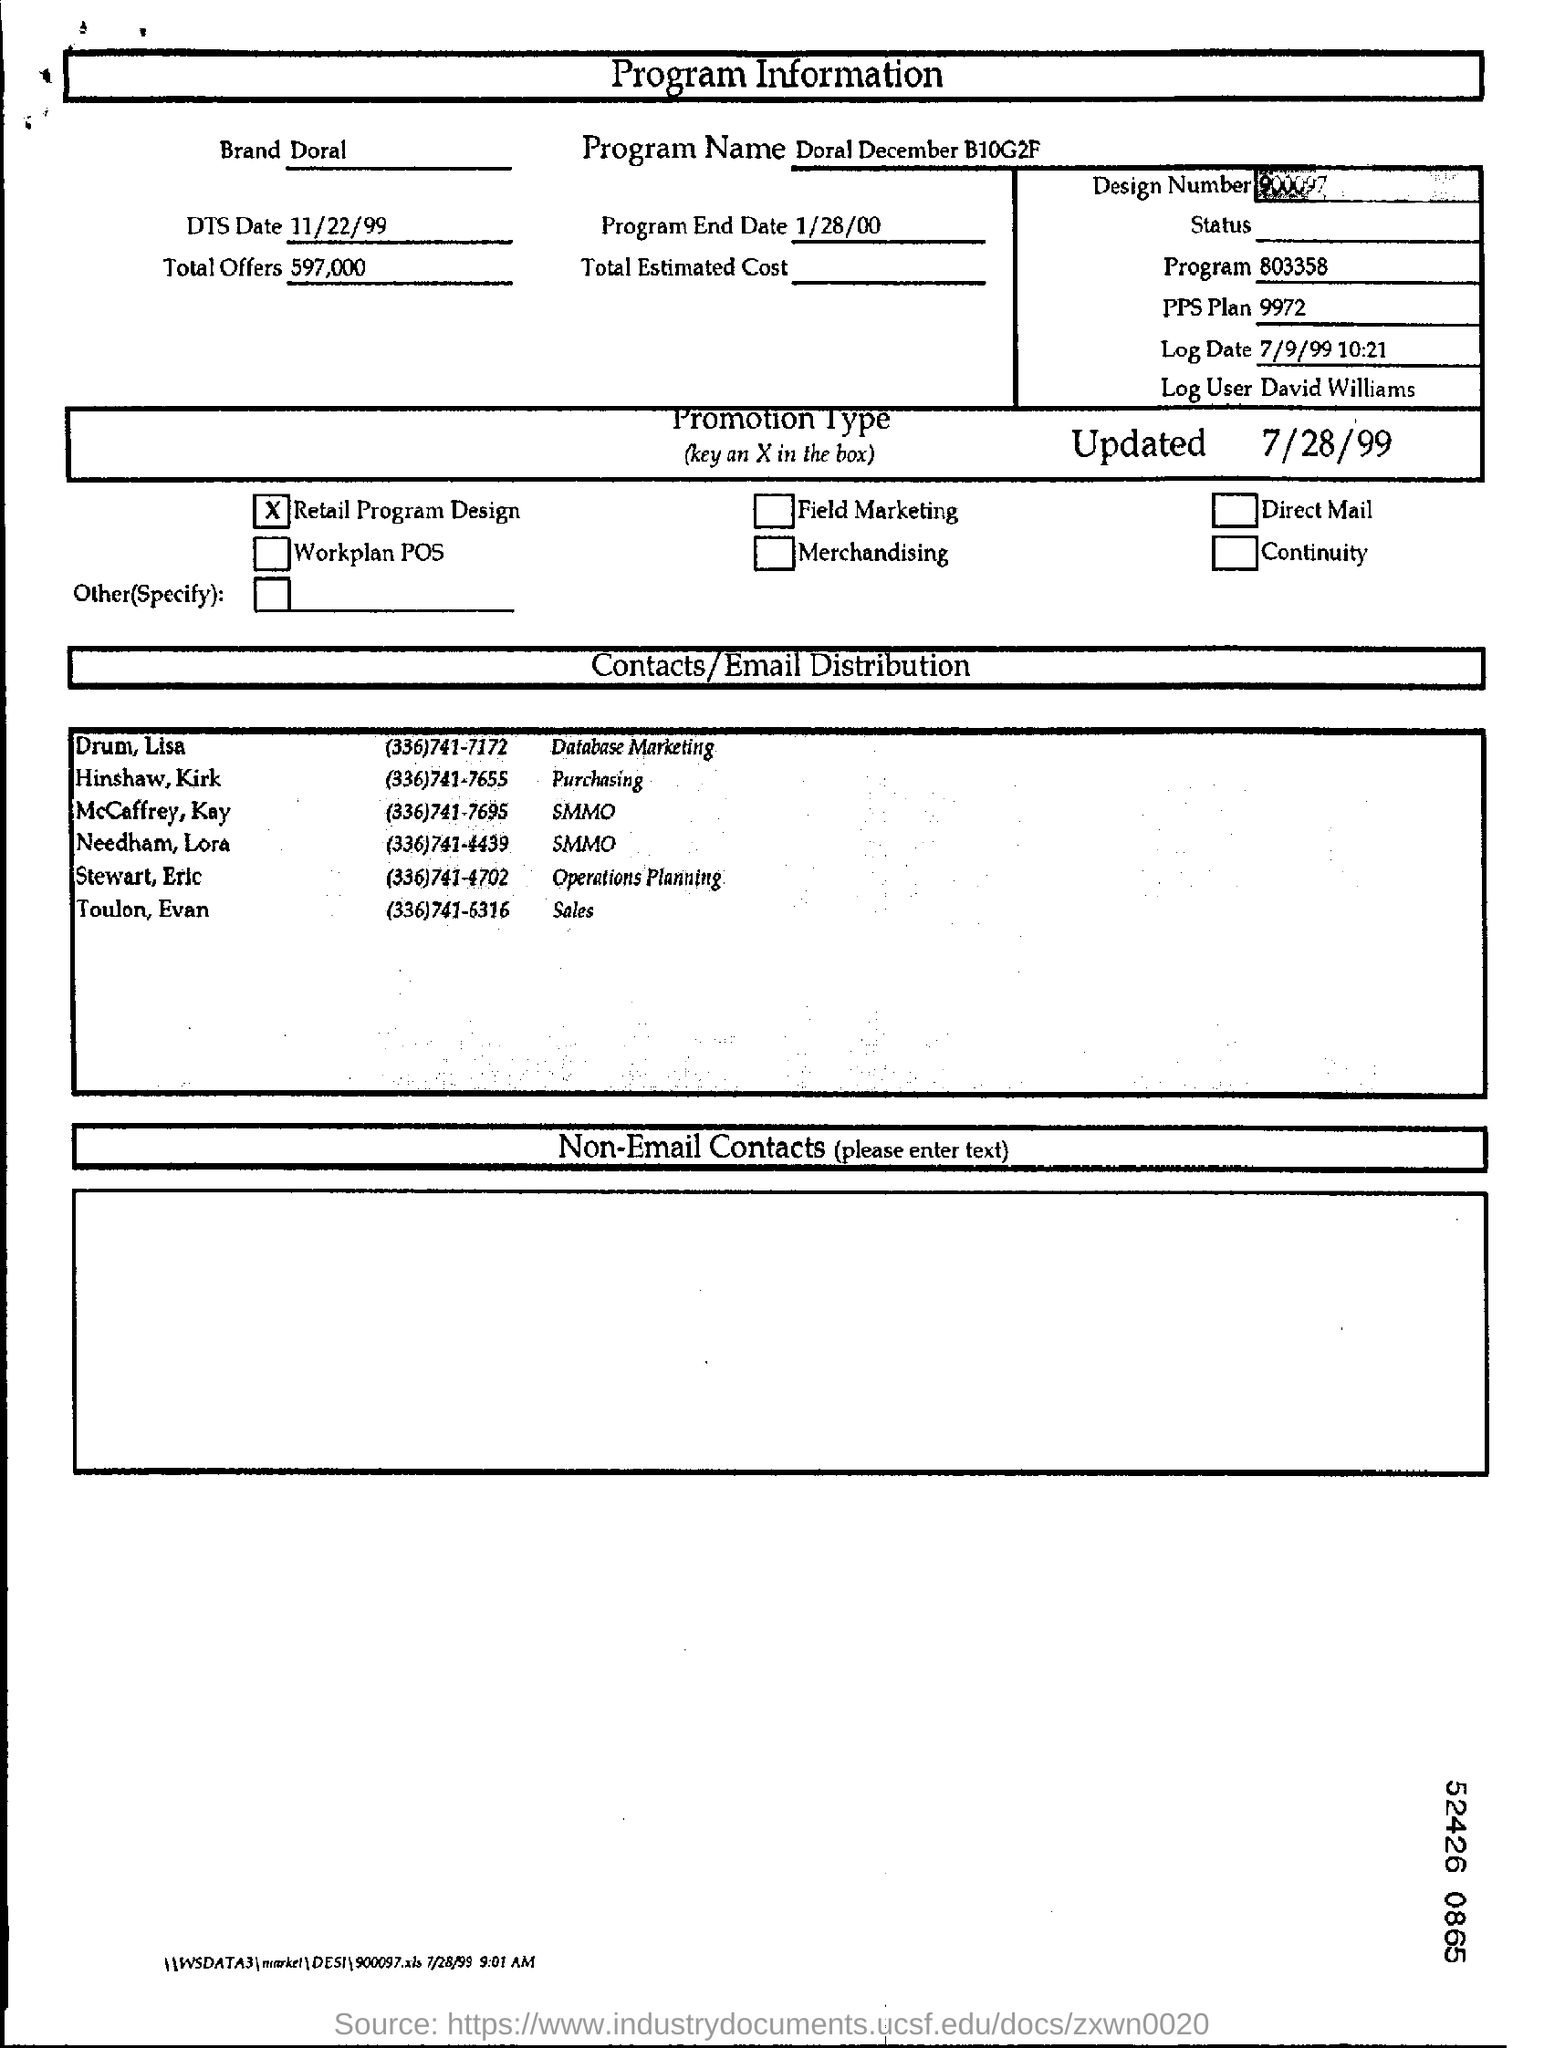Which is the brand mentioned in the program information?
Your answer should be very brief. Doral. What is the program name?
Provide a succinct answer. Doral December B10G2F. How many total offers are mentioned in the form?
Provide a short and direct response. 597,000. Who is to be contacted with regards to Database marketing?
Give a very brief answer. Drum, Lisa. What is the promotion type?
Your answer should be very brief. Retail program design. 